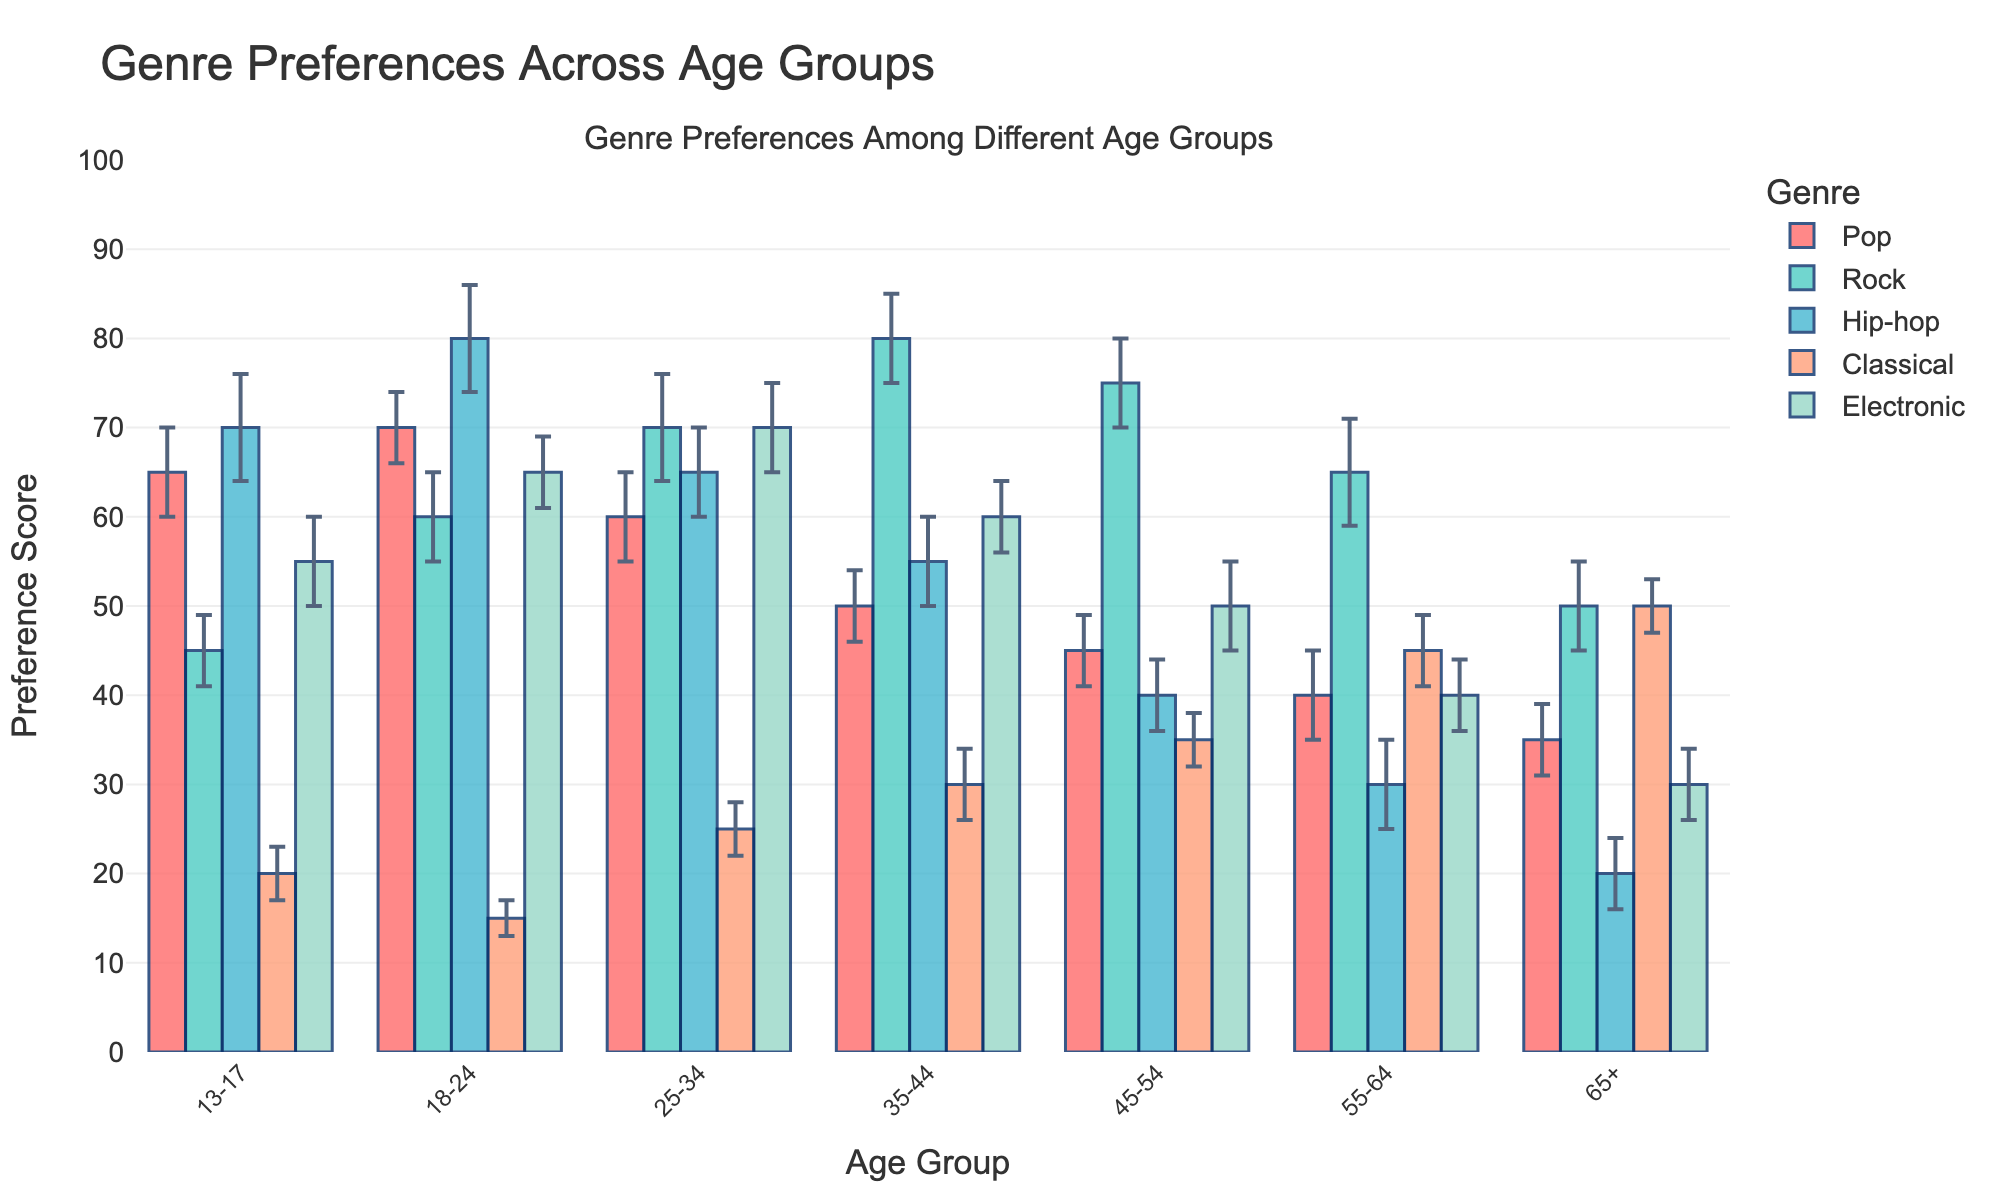what's the title of the chart? The chart's title is given at the top of the figure. The title summarizes what the figure is about.
Answer: Genre Preferences Across Age Groups What is the preference score for Pop among the 18-24 age group? Look at the bar section representing Pop for the 18-24 age group; the bar height indicates the preference score.
Answer: 70 Which age group has the highest preference score for Rock? Analyze the heights of Rock bars across all age groups to find the highest one.
Answer: 35-44 Between which two age groups is the preference for Classical most different, and by how much? Compare the heights of Classical bars for each pair of age groups. The largest difference occurs between 35-44 and 18-24. The difference is 30 - 15.
Answer: 15 For which age group is Electronic the least preferred? Find the smallest bar height for Electronic across all age groups.
Answer: 65+ Which genre has the highest mean preference score overall, and what is the score? Compare the average heights of the bars of each genre and find the maximum.
Answer: Hip-hop (80) What is the range of the preference score for Hip-hop among the age groups 25-34 and 55-64? The preference scores for Hip-hop among 25-34 and 55-64 age groups are 65 and 30, respectively. So, the range is 65 - 30.
Answer: 35 Which two genres have the closest preference scores for the 45-54 age group? Compare the bar heights of the genres for the 45-54 age group to find the two closest ones.
Answer: Hip-hop and Electronic (difference of 10) What is the difference between the highest and lowest preference scores for the Pop genre across age groups? The highest preference score for Pop is 70 (18-24), and the lowest is 35 (65+). The difference is 70 - 35.
Answer: 35 How does the confidence interval for Hip-hop in the 13-17 age group compare to the confidence interval for Classical in the same age group? Compare the lengths representing the confidence interval (CI) for both genres within the 13-17 age group.
Answer: Hip-hop CI is higher by 3 